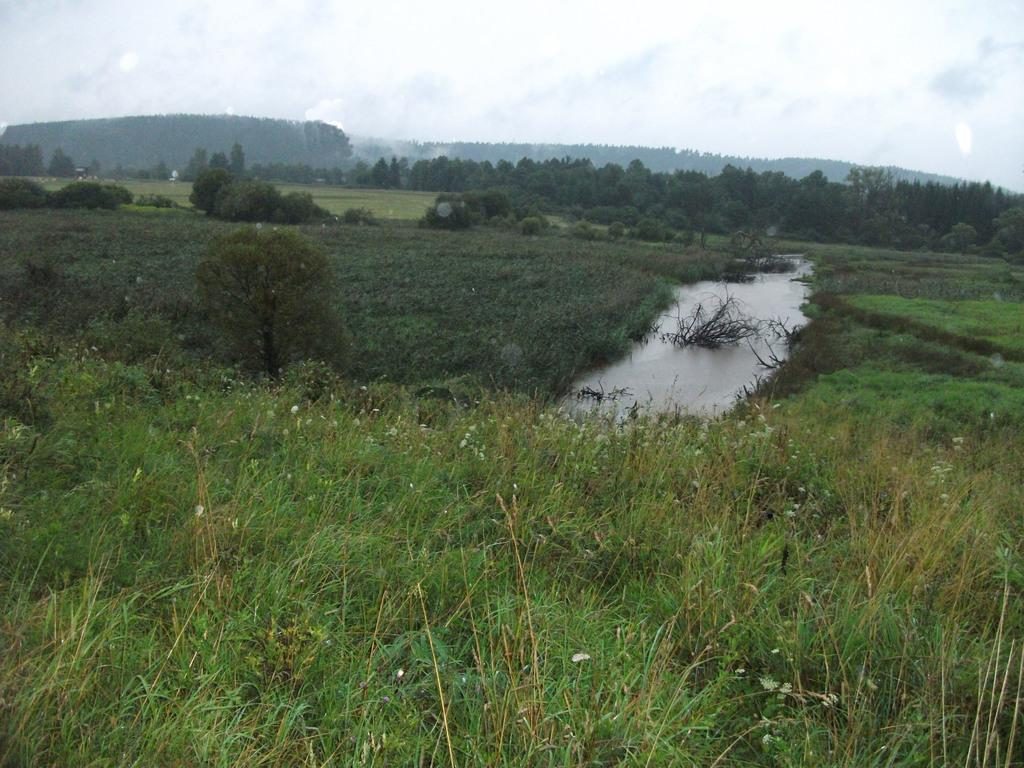What type of vegetation can be seen in the image? There is a group of plants and trees in the image. What body of water is present in the image? There is a pond with water in the image. What can be seen in the background of the image? There are trees and a mountain visible in the background, along with the sky. What type of furniture is present in the image? There is no furniture present in the image; it features a group of plants, trees, a pond, and a mountainous background. 